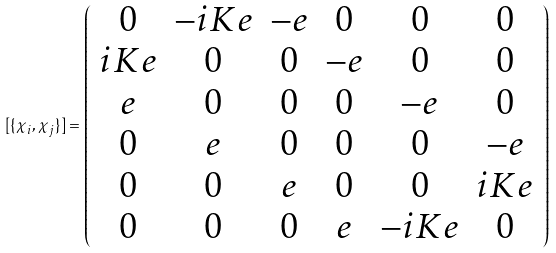Convert formula to latex. <formula><loc_0><loc_0><loc_500><loc_500>[ \{ \chi _ { i } , \chi _ { j } \} ] = \left ( \begin{array} { c c c c c c } 0 & - i K e & - e & 0 & 0 & 0 \\ i K e & 0 & 0 & - e & 0 & 0 \\ e & 0 & 0 & 0 & - e & 0 \\ 0 & e & 0 & 0 & 0 & - e \\ 0 & 0 & e & 0 & 0 & i K e \\ 0 & 0 & 0 & e & - i K e & 0 \end{array} \right )</formula> 